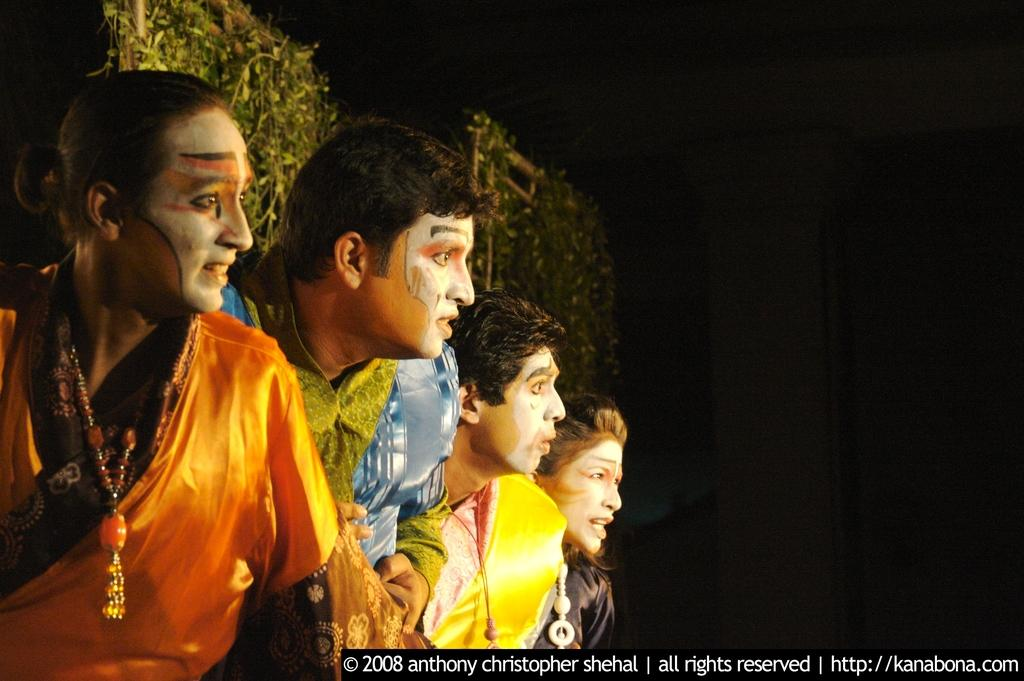How many people are in the image? There are four persons in the image. What are the persons wearing? The persons are wearing costumes. Is there any text present in the image? Yes, there is text at the bottom of the image. What can be seen in the background of the image? There are plants in the background of the image. What type of pet can be seen playing with the persons in the image? There is no pet present in the image; the persons are wearing costumes and there are no animals visible. 